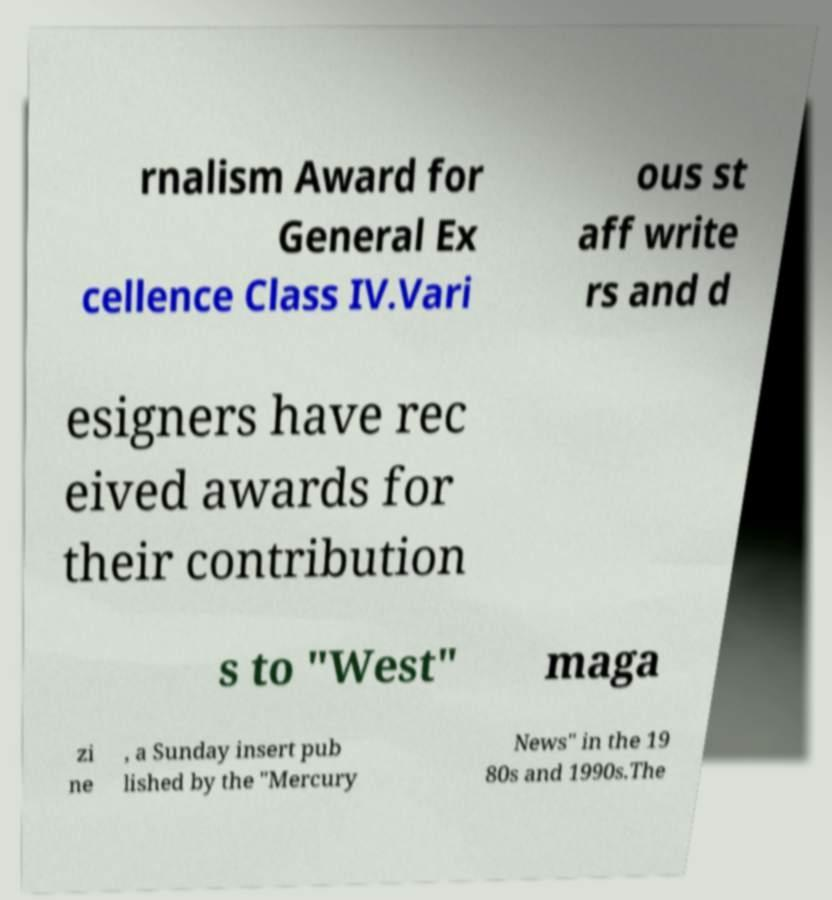Can you read and provide the text displayed in the image?This photo seems to have some interesting text. Can you extract and type it out for me? rnalism Award for General Ex cellence Class IV.Vari ous st aff write rs and d esigners have rec eived awards for their contribution s to "West" maga zi ne , a Sunday insert pub lished by the "Mercury News" in the 19 80s and 1990s.The 